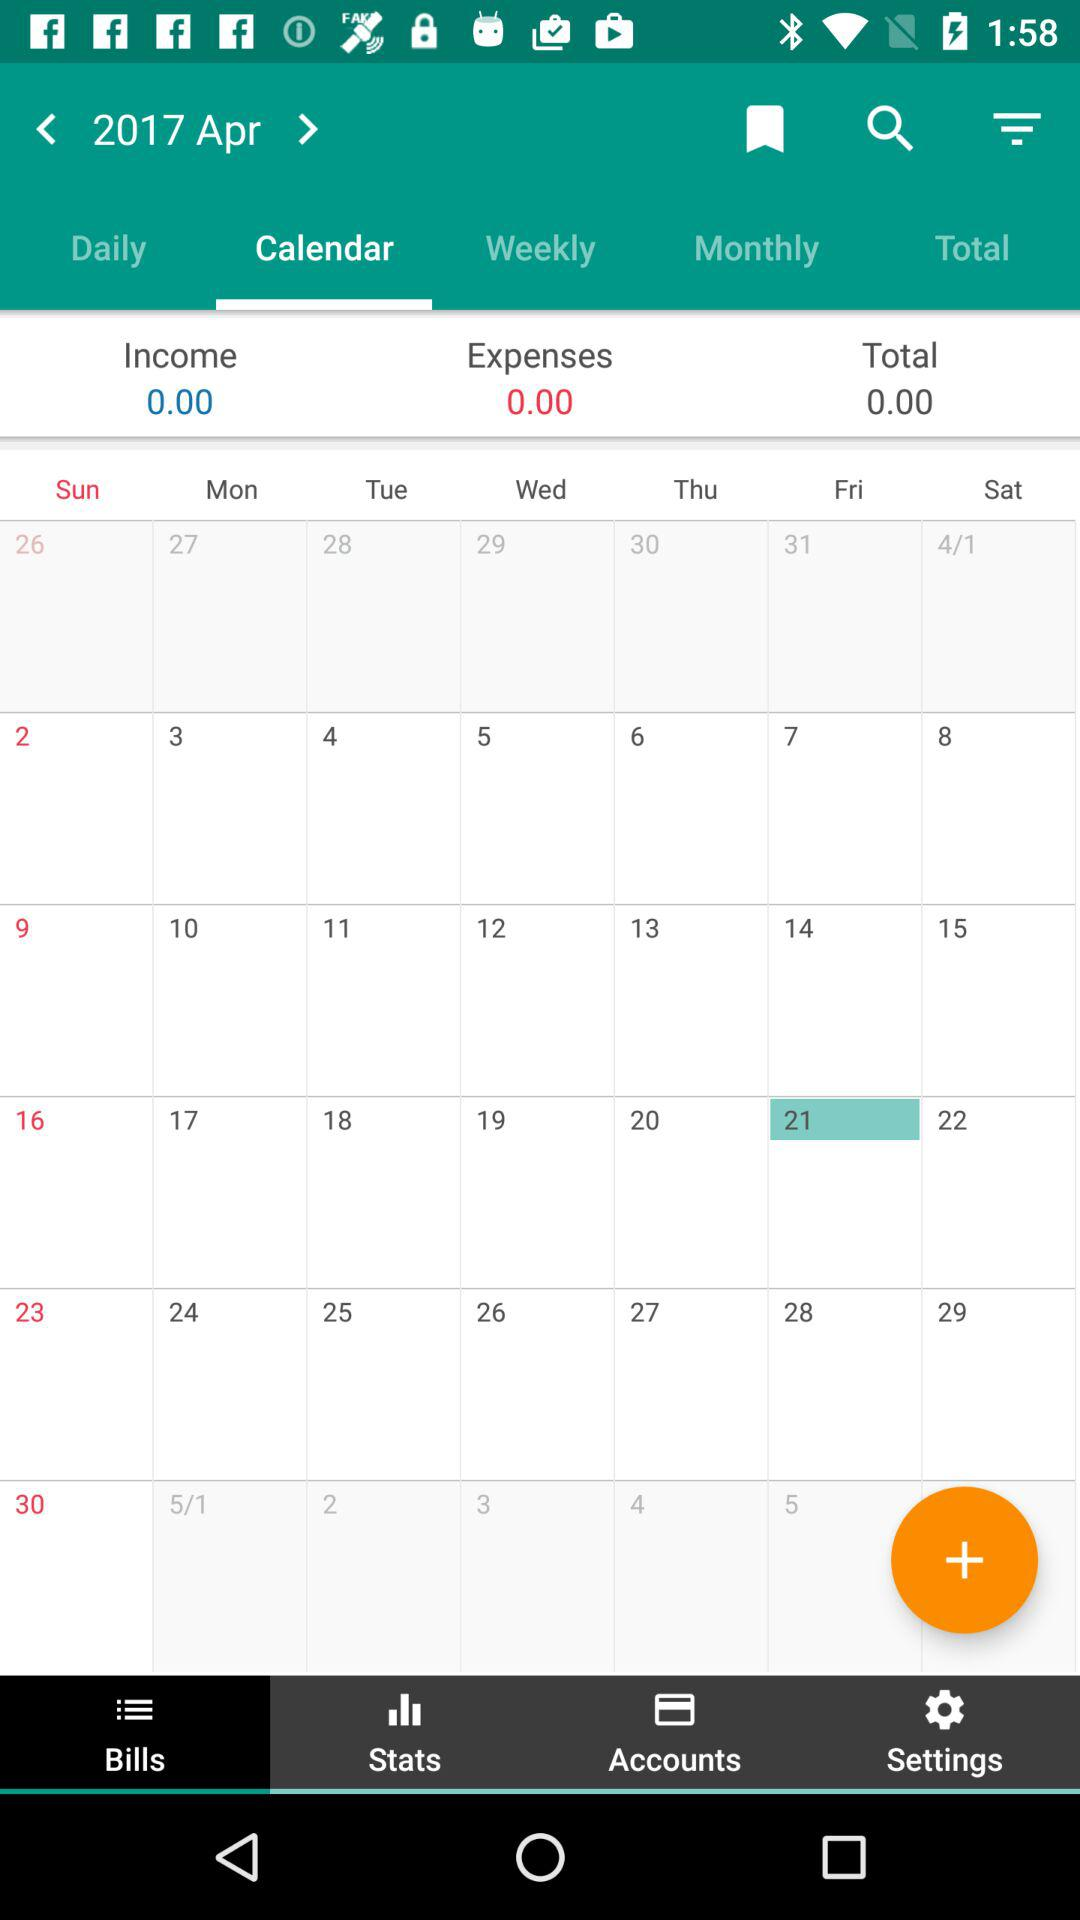Which is the current date? The current date is Friday, April 21, 2017. 